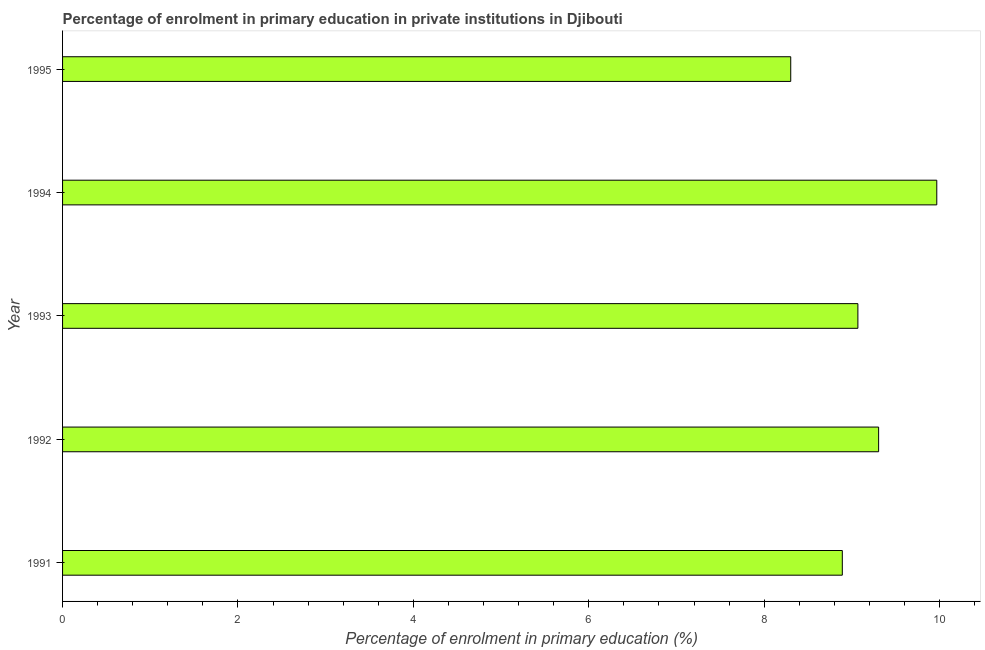Does the graph contain any zero values?
Ensure brevity in your answer.  No. Does the graph contain grids?
Make the answer very short. No. What is the title of the graph?
Give a very brief answer. Percentage of enrolment in primary education in private institutions in Djibouti. What is the label or title of the X-axis?
Your answer should be compact. Percentage of enrolment in primary education (%). What is the enrolment percentage in primary education in 1991?
Ensure brevity in your answer.  8.89. Across all years, what is the maximum enrolment percentage in primary education?
Offer a terse response. 9.97. Across all years, what is the minimum enrolment percentage in primary education?
Offer a terse response. 8.3. In which year was the enrolment percentage in primary education maximum?
Ensure brevity in your answer.  1994. What is the sum of the enrolment percentage in primary education?
Your answer should be compact. 45.54. What is the difference between the enrolment percentage in primary education in 1991 and 1992?
Your answer should be compact. -0.41. What is the average enrolment percentage in primary education per year?
Provide a succinct answer. 9.11. What is the median enrolment percentage in primary education?
Your answer should be compact. 9.07. In how many years, is the enrolment percentage in primary education greater than 7.6 %?
Keep it short and to the point. 5. What is the ratio of the enrolment percentage in primary education in 1992 to that in 1994?
Your response must be concise. 0.93. Is the difference between the enrolment percentage in primary education in 1993 and 1994 greater than the difference between any two years?
Ensure brevity in your answer.  No. What is the difference between the highest and the second highest enrolment percentage in primary education?
Ensure brevity in your answer.  0.66. Is the sum of the enrolment percentage in primary education in 1993 and 1994 greater than the maximum enrolment percentage in primary education across all years?
Your answer should be compact. Yes. What is the difference between the highest and the lowest enrolment percentage in primary education?
Offer a very short reply. 1.67. How many bars are there?
Provide a succinct answer. 5. Are the values on the major ticks of X-axis written in scientific E-notation?
Offer a terse response. No. What is the Percentage of enrolment in primary education (%) in 1991?
Your response must be concise. 8.89. What is the Percentage of enrolment in primary education (%) of 1992?
Give a very brief answer. 9.3. What is the Percentage of enrolment in primary education (%) of 1993?
Make the answer very short. 9.07. What is the Percentage of enrolment in primary education (%) of 1994?
Offer a terse response. 9.97. What is the Percentage of enrolment in primary education (%) in 1995?
Keep it short and to the point. 8.3. What is the difference between the Percentage of enrolment in primary education (%) in 1991 and 1992?
Your answer should be compact. -0.41. What is the difference between the Percentage of enrolment in primary education (%) in 1991 and 1993?
Offer a very short reply. -0.18. What is the difference between the Percentage of enrolment in primary education (%) in 1991 and 1994?
Provide a succinct answer. -1.08. What is the difference between the Percentage of enrolment in primary education (%) in 1991 and 1995?
Give a very brief answer. 0.59. What is the difference between the Percentage of enrolment in primary education (%) in 1992 and 1993?
Make the answer very short. 0.24. What is the difference between the Percentage of enrolment in primary education (%) in 1992 and 1994?
Give a very brief answer. -0.66. What is the difference between the Percentage of enrolment in primary education (%) in 1992 and 1995?
Your response must be concise. 1. What is the difference between the Percentage of enrolment in primary education (%) in 1993 and 1994?
Your response must be concise. -0.9. What is the difference between the Percentage of enrolment in primary education (%) in 1993 and 1995?
Your response must be concise. 0.77. What is the difference between the Percentage of enrolment in primary education (%) in 1994 and 1995?
Provide a short and direct response. 1.67. What is the ratio of the Percentage of enrolment in primary education (%) in 1991 to that in 1992?
Offer a very short reply. 0.96. What is the ratio of the Percentage of enrolment in primary education (%) in 1991 to that in 1994?
Give a very brief answer. 0.89. What is the ratio of the Percentage of enrolment in primary education (%) in 1991 to that in 1995?
Provide a succinct answer. 1.07. What is the ratio of the Percentage of enrolment in primary education (%) in 1992 to that in 1993?
Provide a succinct answer. 1.03. What is the ratio of the Percentage of enrolment in primary education (%) in 1992 to that in 1994?
Your answer should be compact. 0.93. What is the ratio of the Percentage of enrolment in primary education (%) in 1992 to that in 1995?
Offer a very short reply. 1.12. What is the ratio of the Percentage of enrolment in primary education (%) in 1993 to that in 1994?
Make the answer very short. 0.91. What is the ratio of the Percentage of enrolment in primary education (%) in 1993 to that in 1995?
Provide a short and direct response. 1.09. What is the ratio of the Percentage of enrolment in primary education (%) in 1994 to that in 1995?
Offer a very short reply. 1.2. 